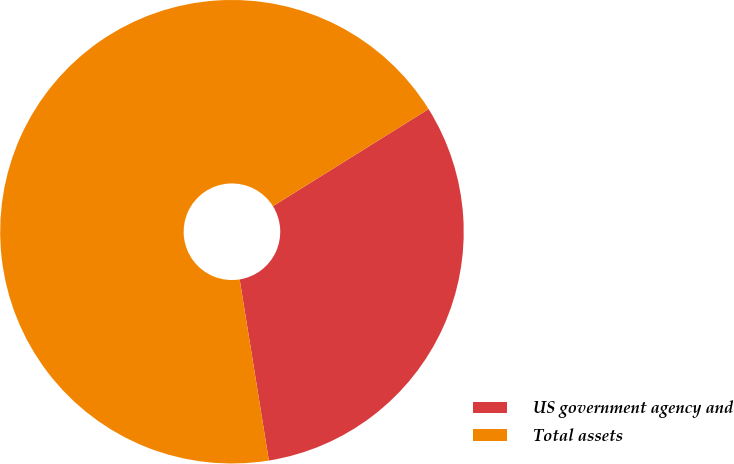Convert chart to OTSL. <chart><loc_0><loc_0><loc_500><loc_500><pie_chart><fcel>US government agency and<fcel>Total assets<nl><fcel>31.33%<fcel>68.67%<nl></chart> 